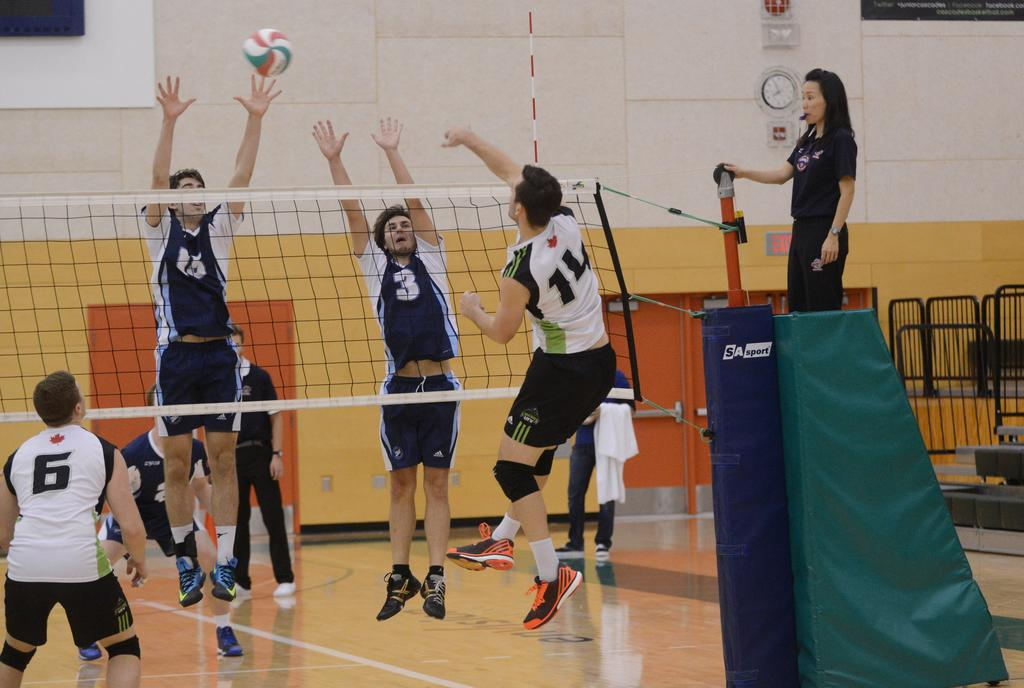<image>
Summarize the visual content of the image. A female referee watches over a game where player number 3 jumps for the volleyball. 